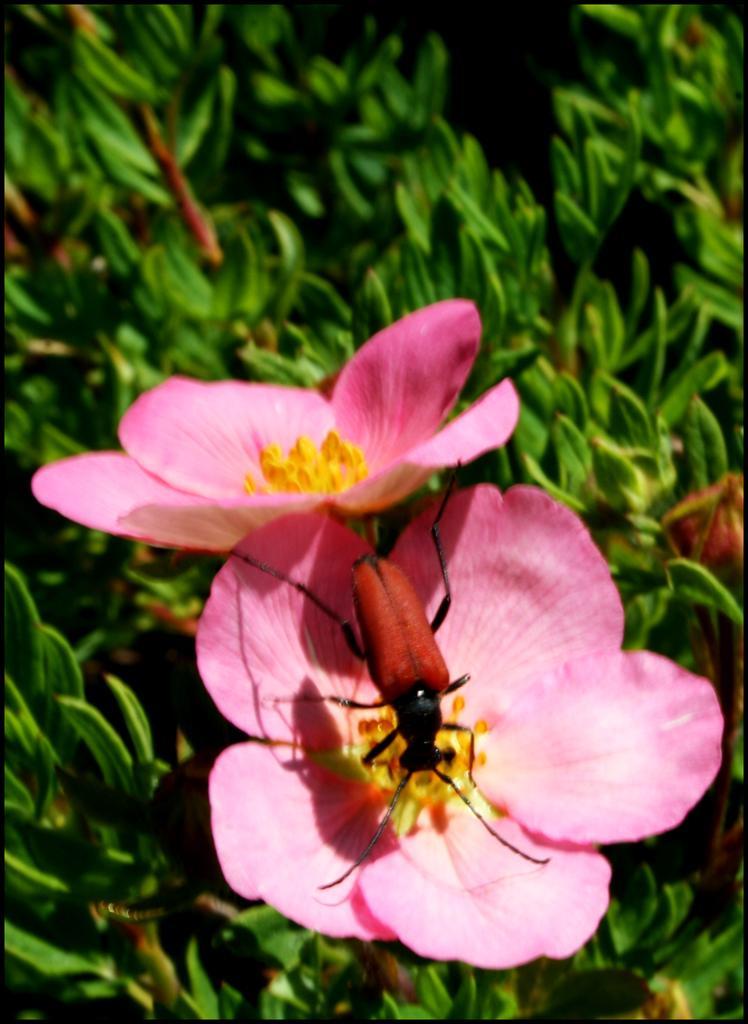In one or two sentences, can you explain what this image depicts? In this image I can see few pink and white color flowers and green color plants. The insect is on the flower. 